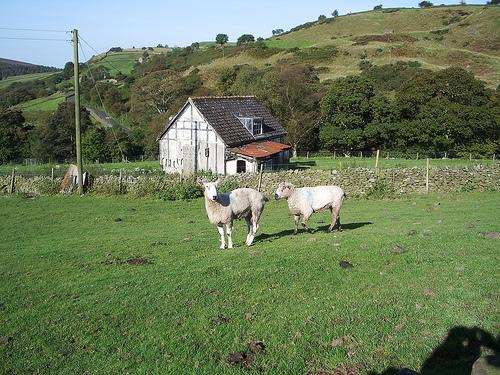Question: how many sheep are there?
Choices:
A. 6.
B. 2.
C. 1.
D. 8.
Answer with the letter. Answer: B Question: who is in the pic?
Choices:
A. No one.
B. A man.
C. Two girls.
D. A girl and a horse.
Answer with the letter. Answer: A Question: what is behind them?
Choices:
A. A school.
B. A museum.
C. A house.
D. A zoo.
Answer with the letter. Answer: C Question: what is the color of the sheep?
Choices:
A. Black.
B. White.
C. Gray.
D. Cream.
Answer with the letter. Answer: B Question: where was the pic taken?
Choices:
A. At a museum.
B. At school.
C. In the field.
D. At home.
Answer with the letter. Answer: C 